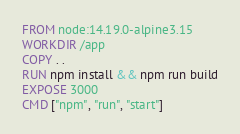<code> <loc_0><loc_0><loc_500><loc_500><_Dockerfile_>FROM node:14.19.0-alpine3.15
WORKDIR /app
COPY . .
RUN npm install && npm run build
EXPOSE 3000
CMD ["npm", "run", "start"]
</code> 